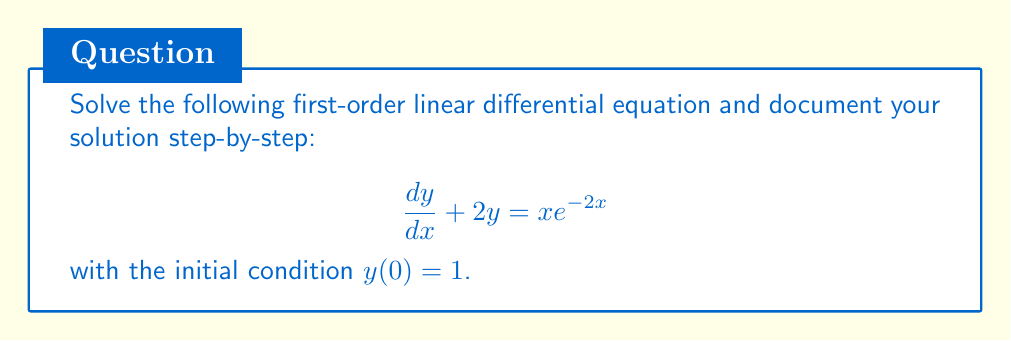Can you answer this question? 1. Identify the equation:
   This is a first-order linear differential equation in the form:
   $$\frac{dy}{dx} + P(x)y = Q(x)$$
   where $P(x) = 2$ and $Q(x) = x e^{-2x}$.

2. Find the integrating factor:
   The integrating factor is given by $\mu(x) = e^{\int P(x) dx}$
   $$\mu(x) = e^{\int 2 dx} = e^{2x}$$

3. Multiply both sides of the equation by the integrating factor:
   $$e^{2x} \frac{dy}{dx} + 2e^{2x}y = xe^{-2x}e^{2x} = x$$

4. Recognize the left side as the derivative of a product:
   $$\frac{d}{dx}(e^{2x}y) = x$$

5. Integrate both sides:
   $$\int \frac{d}{dx}(e^{2x}y) dx = \int x dx$$
   $$e^{2x}y = \frac{1}{2}x^2 + C$$

6. Solve for y:
   $$y = \frac{1}{2}x^2e^{-2x} + Ce^{-2x}$$

7. Apply the initial condition $y(0) = 1$ to find C:
   $$1 = \frac{1}{2}(0)^2e^{-2(0)} + Ce^{-2(0)}$$
   $$1 = C$$

8. Write the final solution:
   $$y = \frac{1}{2}x^2e^{-2x} + e^{-2x}$$

9. Document the solution process:
   - Identified the equation type
   - Found the integrating factor
   - Multiplied by the integrating factor
   - Integrated both sides
   - Solved for y
   - Applied the initial condition
   - Wrote the final solution
Answer: The solution to the given first-order linear differential equation is:

$$y = \frac{1}{2}x^2e^{-2x} + e^{-2x}$$ 